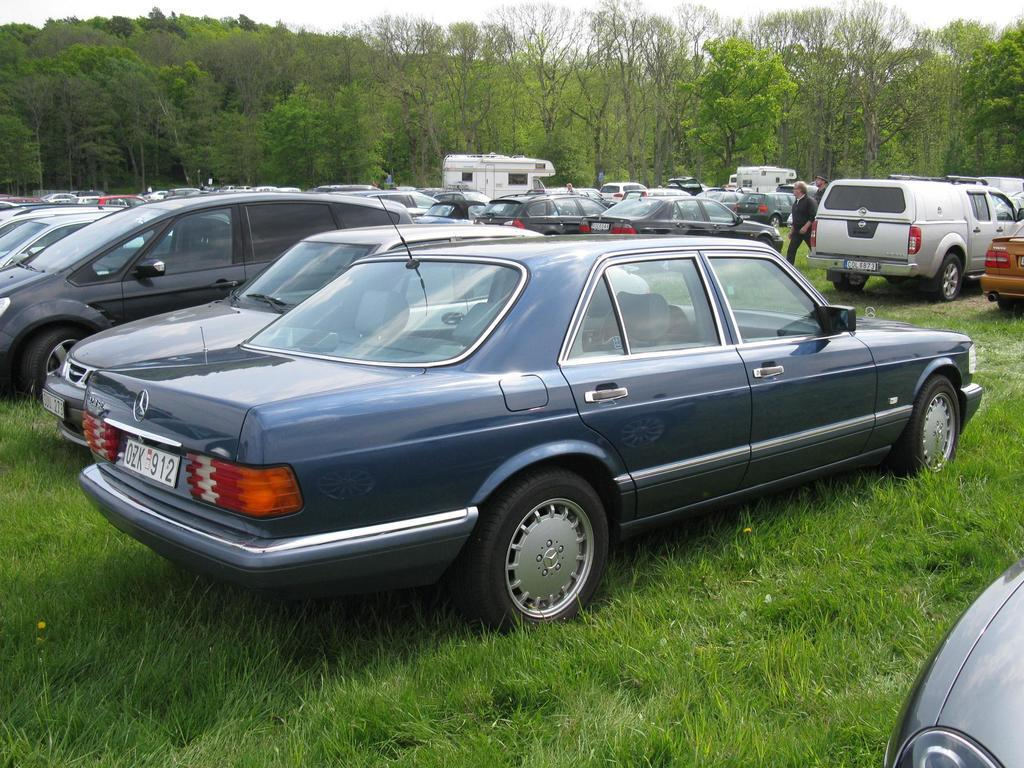<image>
Describe the image concisely. cars parked in a field and one has a license plate reading OZK 912 